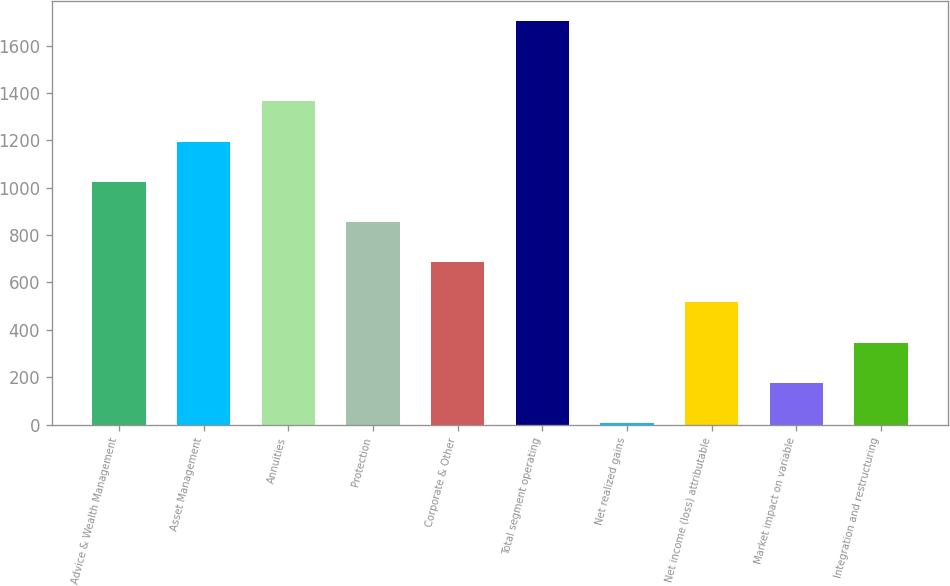<chart> <loc_0><loc_0><loc_500><loc_500><bar_chart><fcel>Advice & Wealth Management<fcel>Asset Management<fcel>Annuities<fcel>Protection<fcel>Corporate & Other<fcel>Total segment operating<fcel>Net realized gains<fcel>Net income (loss) attributable<fcel>Market impact on variable<fcel>Integration and restructuring<nl><fcel>1024.8<fcel>1194.6<fcel>1364.4<fcel>855<fcel>685.2<fcel>1704<fcel>6<fcel>515.4<fcel>175.8<fcel>345.6<nl></chart> 